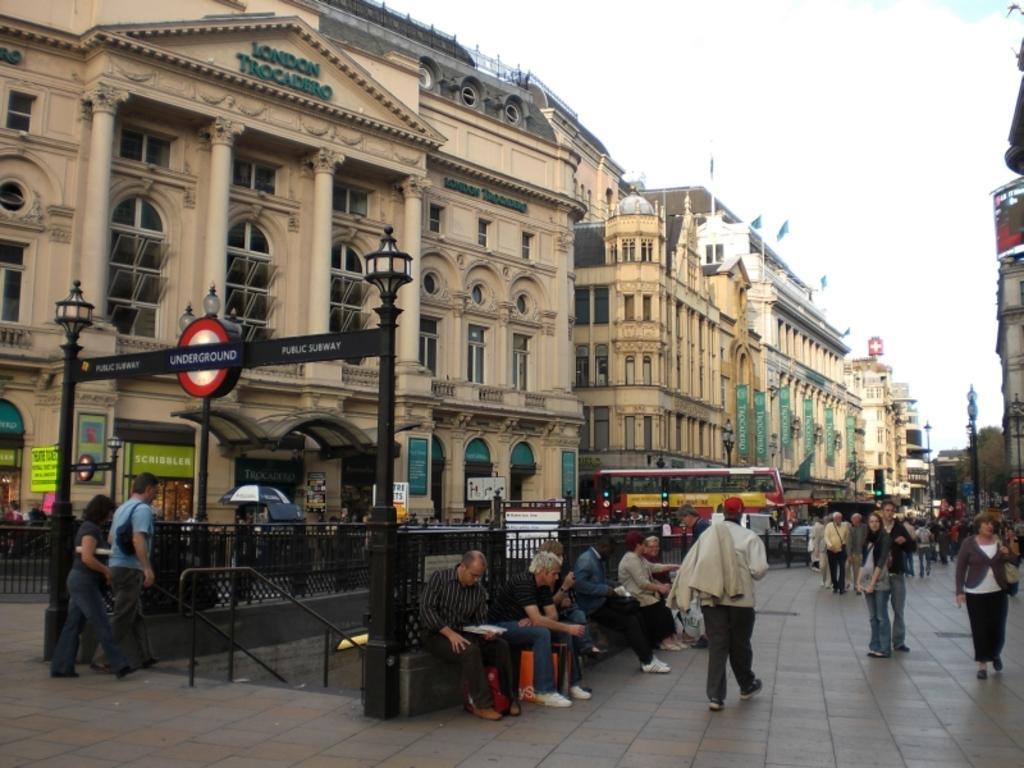Can you describe this image briefly? In this image I can see group of people some are standing and some are sitting. The person in front wearing white shirt, gray pant. Background I can see few light poles, buildings in cream and white color and sky in white color. 